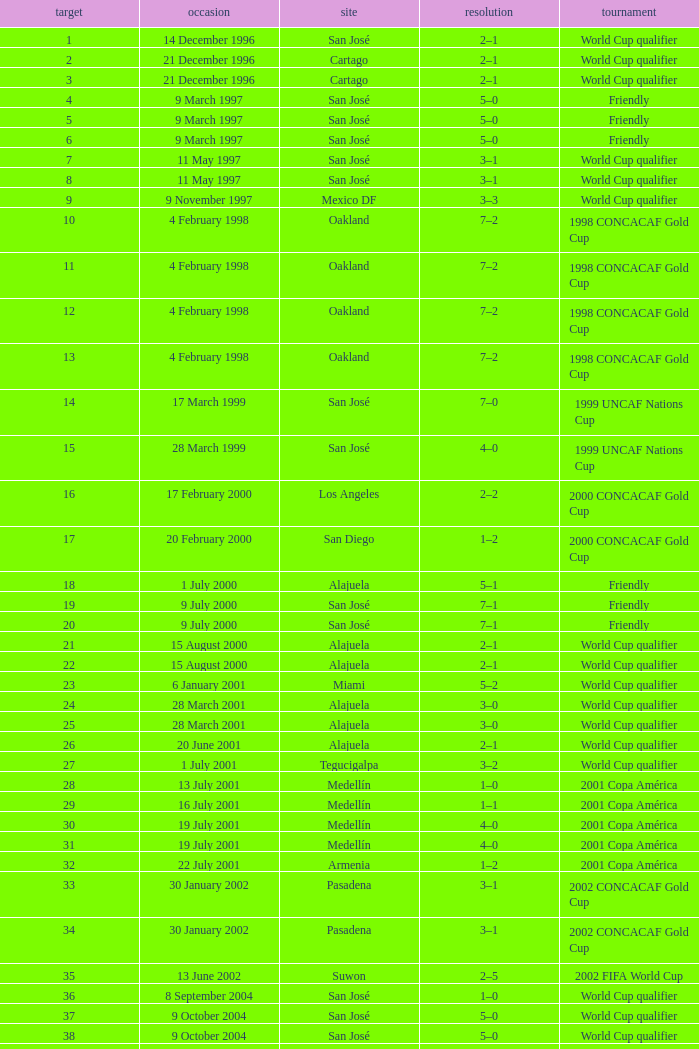What is the result in oakland? 7–2, 7–2, 7–2, 7–2. 